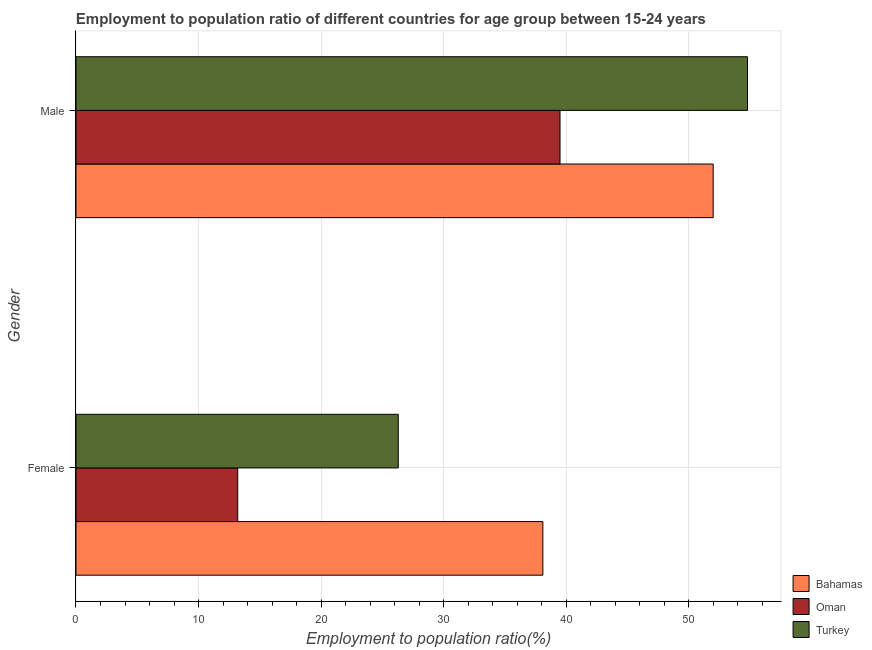How many different coloured bars are there?
Offer a terse response. 3. How many groups of bars are there?
Provide a succinct answer. 2. How many bars are there on the 2nd tick from the top?
Make the answer very short. 3. How many bars are there on the 1st tick from the bottom?
Give a very brief answer. 3. What is the label of the 1st group of bars from the top?
Make the answer very short. Male. What is the employment to population ratio(female) in Oman?
Your answer should be very brief. 13.2. Across all countries, what is the maximum employment to population ratio(female)?
Ensure brevity in your answer.  38.1. Across all countries, what is the minimum employment to population ratio(male)?
Provide a succinct answer. 39.5. In which country was the employment to population ratio(female) maximum?
Your response must be concise. Bahamas. In which country was the employment to population ratio(male) minimum?
Offer a very short reply. Oman. What is the total employment to population ratio(female) in the graph?
Your answer should be very brief. 77.6. What is the difference between the employment to population ratio(male) in Oman and that in Bahamas?
Provide a succinct answer. -12.5. What is the difference between the employment to population ratio(female) in Oman and the employment to population ratio(male) in Bahamas?
Give a very brief answer. -38.8. What is the average employment to population ratio(male) per country?
Give a very brief answer. 48.77. What is the difference between the employment to population ratio(female) and employment to population ratio(male) in Oman?
Make the answer very short. -26.3. In how many countries, is the employment to population ratio(male) greater than 26 %?
Ensure brevity in your answer.  3. What is the ratio of the employment to population ratio(female) in Oman to that in Turkey?
Your answer should be compact. 0.5. What does the 2nd bar from the bottom in Female represents?
Make the answer very short. Oman. How many bars are there?
Offer a very short reply. 6. What is the difference between two consecutive major ticks on the X-axis?
Provide a succinct answer. 10. Are the values on the major ticks of X-axis written in scientific E-notation?
Your response must be concise. No. How many legend labels are there?
Offer a terse response. 3. What is the title of the graph?
Your answer should be compact. Employment to population ratio of different countries for age group between 15-24 years. What is the label or title of the X-axis?
Ensure brevity in your answer.  Employment to population ratio(%). What is the label or title of the Y-axis?
Your answer should be compact. Gender. What is the Employment to population ratio(%) in Bahamas in Female?
Ensure brevity in your answer.  38.1. What is the Employment to population ratio(%) in Oman in Female?
Your answer should be compact. 13.2. What is the Employment to population ratio(%) of Turkey in Female?
Provide a short and direct response. 26.3. What is the Employment to population ratio(%) of Bahamas in Male?
Keep it short and to the point. 52. What is the Employment to population ratio(%) in Oman in Male?
Your answer should be very brief. 39.5. What is the Employment to population ratio(%) of Turkey in Male?
Make the answer very short. 54.8. Across all Gender, what is the maximum Employment to population ratio(%) of Bahamas?
Your answer should be very brief. 52. Across all Gender, what is the maximum Employment to population ratio(%) in Oman?
Your response must be concise. 39.5. Across all Gender, what is the maximum Employment to population ratio(%) of Turkey?
Offer a terse response. 54.8. Across all Gender, what is the minimum Employment to population ratio(%) in Bahamas?
Provide a short and direct response. 38.1. Across all Gender, what is the minimum Employment to population ratio(%) of Oman?
Keep it short and to the point. 13.2. Across all Gender, what is the minimum Employment to population ratio(%) of Turkey?
Provide a succinct answer. 26.3. What is the total Employment to population ratio(%) in Bahamas in the graph?
Your answer should be very brief. 90.1. What is the total Employment to population ratio(%) of Oman in the graph?
Offer a very short reply. 52.7. What is the total Employment to population ratio(%) in Turkey in the graph?
Give a very brief answer. 81.1. What is the difference between the Employment to population ratio(%) of Bahamas in Female and that in Male?
Your answer should be very brief. -13.9. What is the difference between the Employment to population ratio(%) of Oman in Female and that in Male?
Your answer should be compact. -26.3. What is the difference between the Employment to population ratio(%) in Turkey in Female and that in Male?
Provide a succinct answer. -28.5. What is the difference between the Employment to population ratio(%) of Bahamas in Female and the Employment to population ratio(%) of Oman in Male?
Offer a terse response. -1.4. What is the difference between the Employment to population ratio(%) of Bahamas in Female and the Employment to population ratio(%) of Turkey in Male?
Provide a succinct answer. -16.7. What is the difference between the Employment to population ratio(%) of Oman in Female and the Employment to population ratio(%) of Turkey in Male?
Keep it short and to the point. -41.6. What is the average Employment to population ratio(%) in Bahamas per Gender?
Your answer should be compact. 45.05. What is the average Employment to population ratio(%) in Oman per Gender?
Offer a very short reply. 26.35. What is the average Employment to population ratio(%) of Turkey per Gender?
Your answer should be compact. 40.55. What is the difference between the Employment to population ratio(%) of Bahamas and Employment to population ratio(%) of Oman in Female?
Offer a very short reply. 24.9. What is the difference between the Employment to population ratio(%) of Bahamas and Employment to population ratio(%) of Turkey in Female?
Keep it short and to the point. 11.8. What is the difference between the Employment to population ratio(%) of Oman and Employment to population ratio(%) of Turkey in Male?
Offer a very short reply. -15.3. What is the ratio of the Employment to population ratio(%) in Bahamas in Female to that in Male?
Your answer should be very brief. 0.73. What is the ratio of the Employment to population ratio(%) in Oman in Female to that in Male?
Provide a short and direct response. 0.33. What is the ratio of the Employment to population ratio(%) in Turkey in Female to that in Male?
Provide a short and direct response. 0.48. What is the difference between the highest and the second highest Employment to population ratio(%) of Oman?
Ensure brevity in your answer.  26.3. What is the difference between the highest and the lowest Employment to population ratio(%) of Bahamas?
Give a very brief answer. 13.9. What is the difference between the highest and the lowest Employment to population ratio(%) of Oman?
Ensure brevity in your answer.  26.3. 